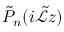Convert formula to latex. <formula><loc_0><loc_0><loc_500><loc_500>\tilde { P } _ { n } ( i \tilde { \mathcal { L } } z )</formula> 